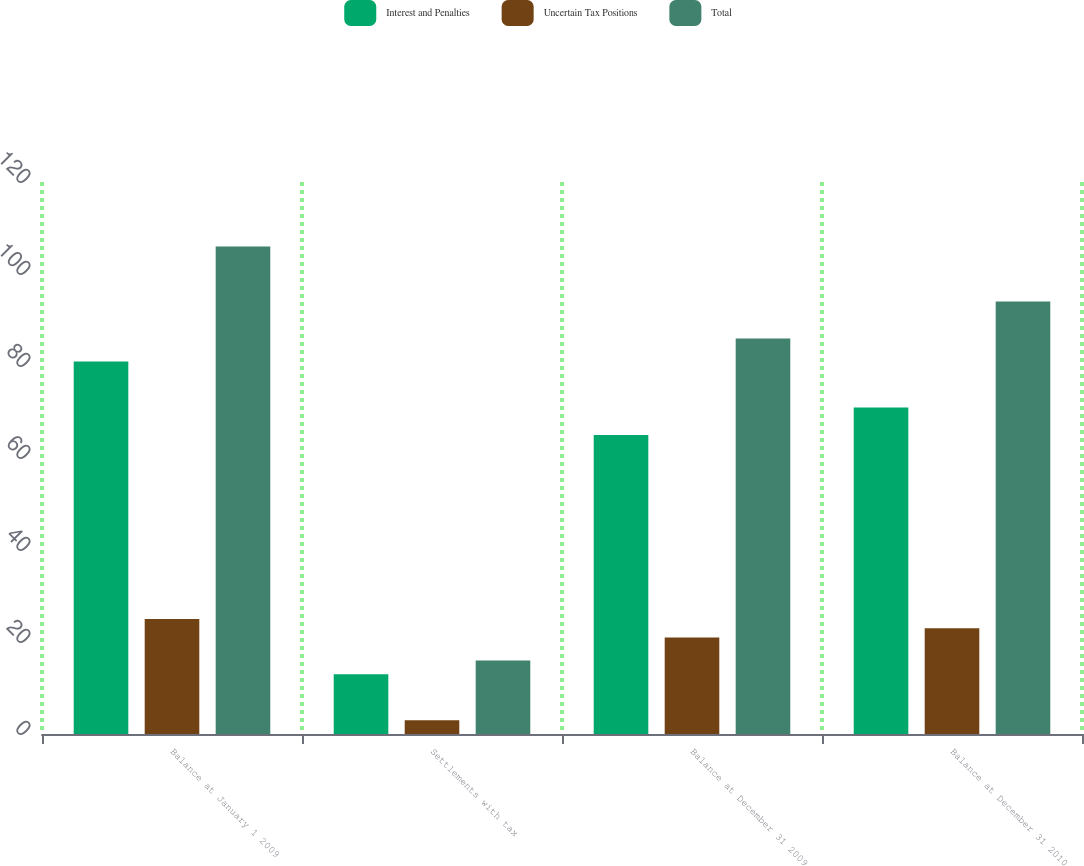Convert chart to OTSL. <chart><loc_0><loc_0><loc_500><loc_500><stacked_bar_chart><ecel><fcel>Balance at January 1 2009<fcel>Settlements with tax<fcel>Balance at December 31 2009<fcel>Balance at December 31 2010<nl><fcel>Interest and Penalties<fcel>81<fcel>13<fcel>65<fcel>71<nl><fcel>Uncertain Tax Positions<fcel>25<fcel>3<fcel>21<fcel>23<nl><fcel>Total<fcel>106<fcel>16<fcel>86<fcel>94<nl></chart> 